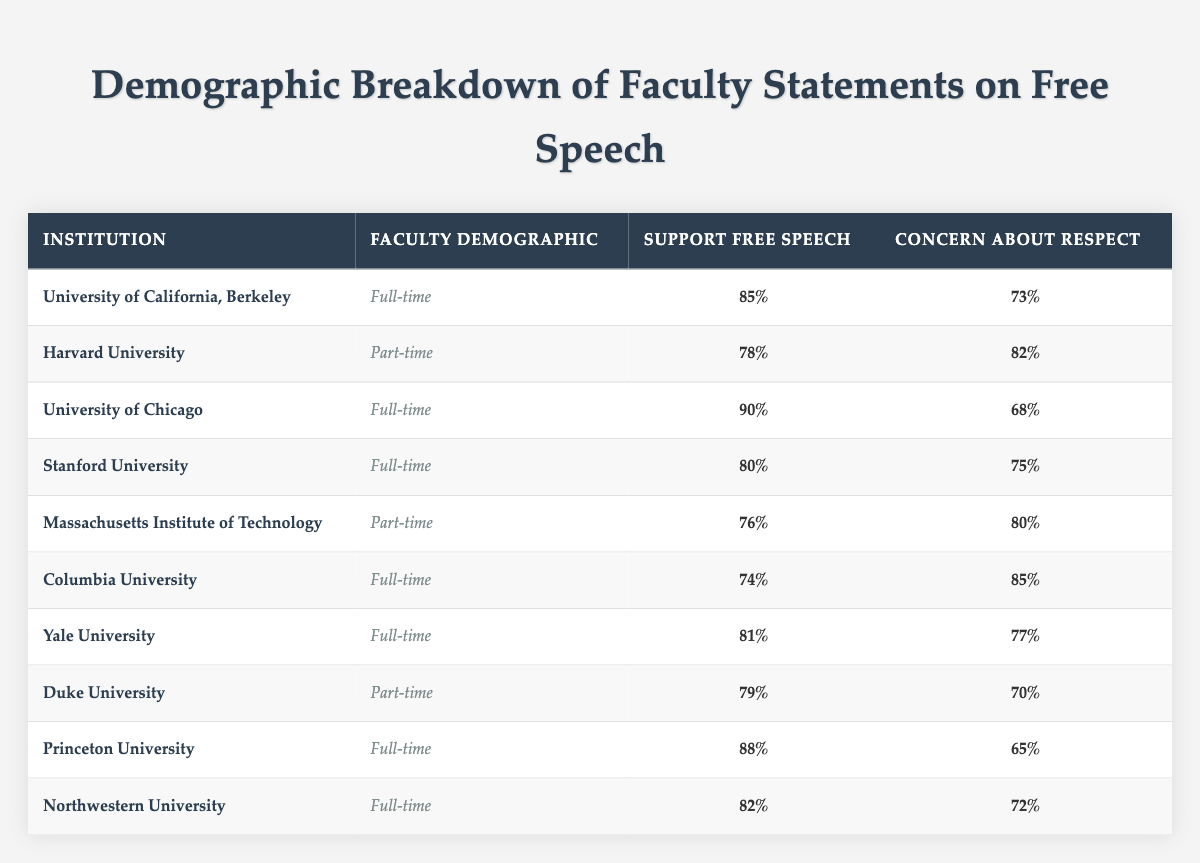What percentage of full-time faculty at Harvard University support free speech? According to the table, Harvard University has part-time faculty, so it does not provide data for full-time faculty. The support for free speech percentage is 78 for part-time faculty.
Answer: 78 What is the highest percentage of support for free speech among full-time faculty? Looking through the table, the highest percentage for full-time faculty is found at the University of Chicago, which has a support percentage of 90.
Answer: 90 Which institution has the lowest percentage of concern about respect among full-time faculty? The table shows that Princeton University has the lowest percentage of concern about respect at 65 for full-time faculty members.
Answer: 65 How many full-time faculty members support free speech at Columbia University compared to Stanford University? Columbia University has 74 support for free speech, while Stanford University has 80. The difference is 80 - 74 = 6.
Answer: 6 What is the average concern about respect among part-time faculty across the institutions listed? Calculating the average concern about respect for part-time faculty: Harvard (82) + MIT (80) + Duke (70), giving a sum of 232, and since there are 3 institutions, the average is 232/3 = approximately 77.33.
Answer: 77.33 Is there any institution where full-time faculty have more concern about respect than concern for free speech? Upon reviewing the table, Columbia University is the only institution where full-time faculty have a higher concern about respect (85) than support for free speech (74).
Answer: Yes Which faculty demographic has a higher average support for free speech, full-time or part-time? To compare, calculate the averages: Full-time: (85 + 90 + 80 + 74 + 81 + 88 + 82) / 7 = 82.14; Part-time: (78 + 76 + 79) / 3 = 77.67. Thus, full-time faculty have a higher average support for free speech.
Answer: Full-time How many institutions have a support for free speech of 80% or higher? The institutions with support percentages of 80 or higher are UC Berkeley (85), University of Chicago (90), Stanford University (80), Princeton University (88), and Northwestern University (82), totaling 5 institutions.
Answer: 5 What percentage of faculty at Duke University is concerned about respect? The percentage of concern about respect for faculty at Duke University is 70, as indicated in the table.
Answer: 70 Is the concern about respect among full-time faculty at Yale University higher than at Columbia University? Yale has a concern about respect of 77 while Columbia has 85. Since 77 is less than 85, the concern at Yale is not higher.
Answer: No 